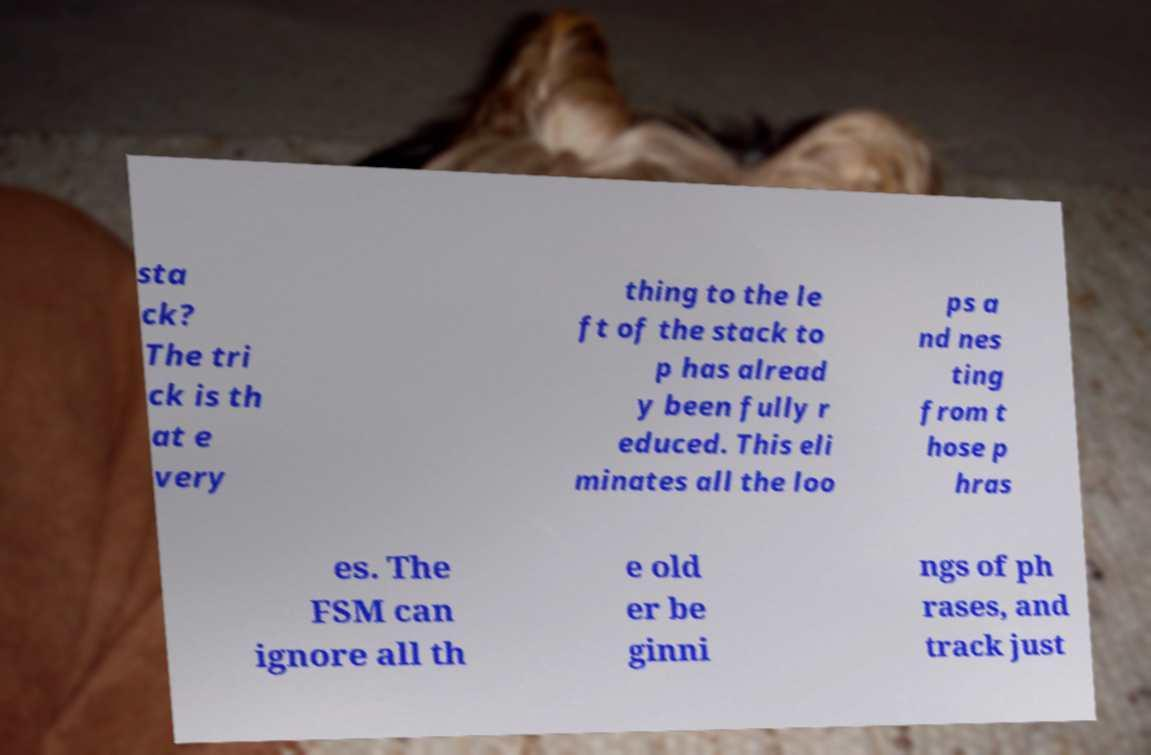Could you extract and type out the text from this image? sta ck? The tri ck is th at e very thing to the le ft of the stack to p has alread y been fully r educed. This eli minates all the loo ps a nd nes ting from t hose p hras es. The FSM can ignore all th e old er be ginni ngs of ph rases, and track just 